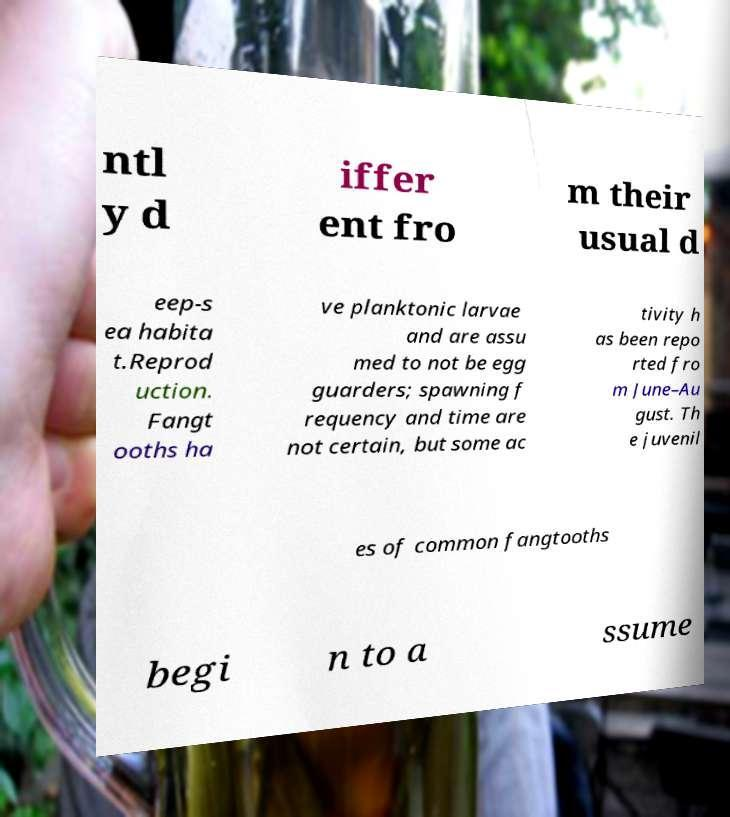Can you read and provide the text displayed in the image?This photo seems to have some interesting text. Can you extract and type it out for me? ntl y d iffer ent fro m their usual d eep-s ea habita t.Reprod uction. Fangt ooths ha ve planktonic larvae and are assu med to not be egg guarders; spawning f requency and time are not certain, but some ac tivity h as been repo rted fro m June–Au gust. Th e juvenil es of common fangtooths begi n to a ssume 